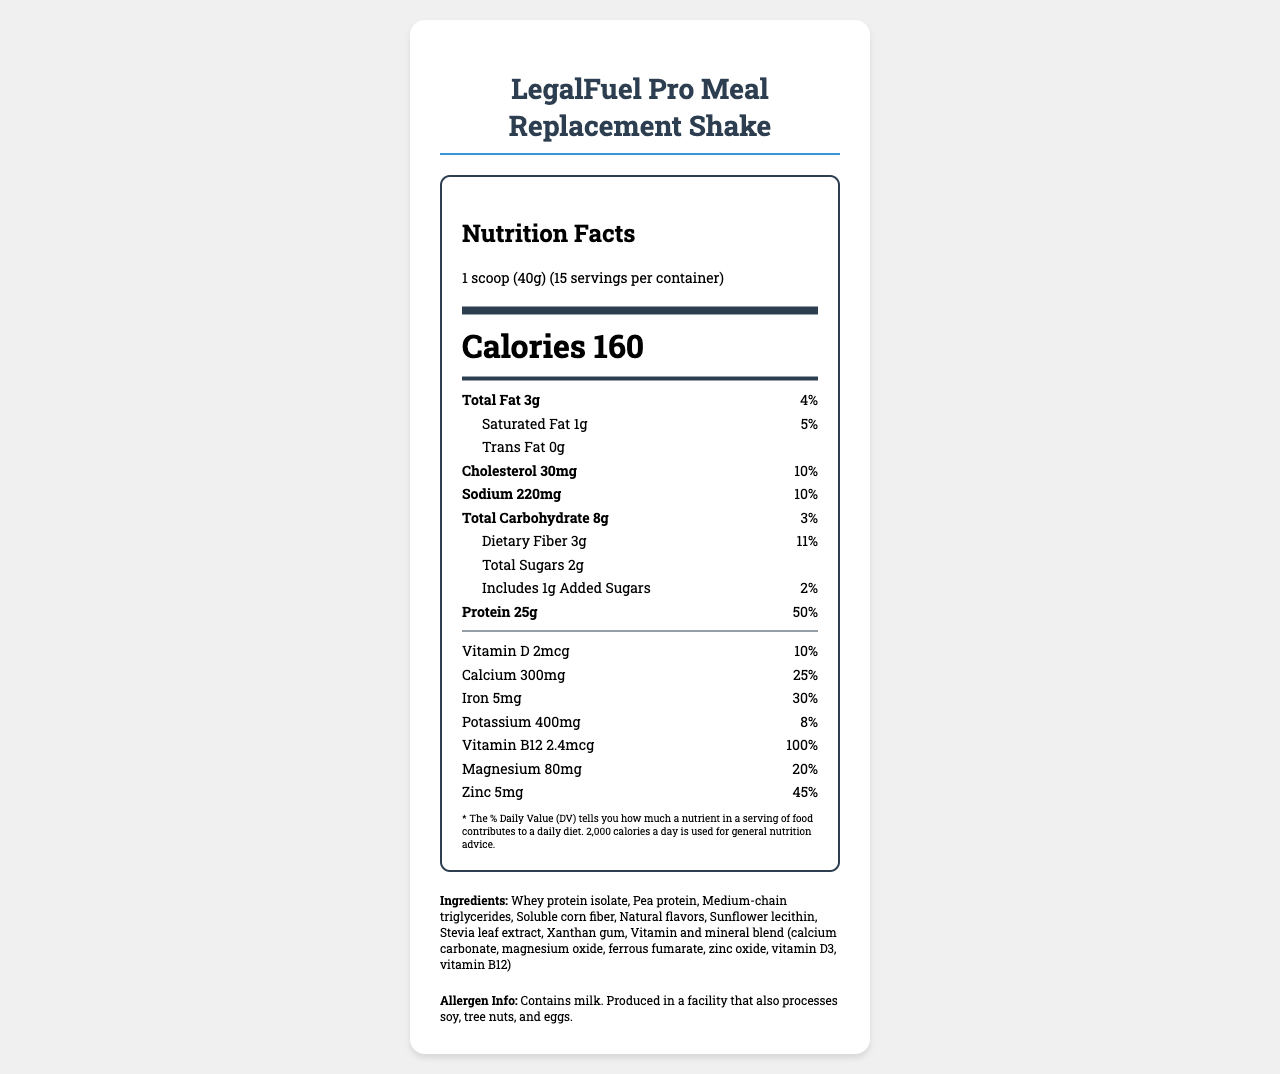what is the product name? The product name is stated at the top of the document.
Answer: LegalFuel Pro Meal Replacement Shake what is the serving size? The serving size is displayed right below the product name within the nutrition label.
Answer: 1 scoop (40g) how many calories are there per serving? The number of calories per serving is clearly indicated in bold, large font on the nutrition facts label.
Answer: 160 what is the amount of total sugars per serving? The amount of total sugars is listed under the carbohydrate section of the nutrition facts label.
Answer: 2g what is the daily value percentage for protein? The daily value percentage for protein is provided in the protein section of the nutrition facts label.
Answer: 50% does this product contain any allergens? The allergen information states that it contains milk and is produced in a facility that processes soy, tree nuts, and eggs.
Answer: Yes how many servings are there per container? The number of servings per container is given in the serving information below the nutrition facts heading.
Answer: 15 what are the total fats per serving, and what is their daily value percentage? The total fat amount is 3g and its daily value percentage is listed as 4% in the fats section of the nutrition label.
Answer: 3g, 4% what is the amount of dietary fiber per serving? The dietary fiber amount is listed under the carbohydrate section of the nutrition facts label.
Answer: 3g what are the product claims made on the document? These product claims are stated under the preparation instructions and product claims section of the document.
Answer: High in protein, Low in sugar, Good source of fiber, Contains essential vitamins and minerals what is the daily value percentage for cholesterol? A. 5% B. 10% C. 15% D. 20% The daily value percentage for cholesterol is listed as 10% in the relevant section of the nutrition facts label.
Answer: B. 10% which vitamin does the product provide 100% of the daily value? A. Vitamin D B. Vitamin B12 C. Vitamin A D. Vitamin C The document states that the product provides 100% of the daily value for Vitamin B12, as indicated in the vitamin section.
Answer: B. Vitamin B12 is the product suitable for vegans? The allergen info indicates the presence of milk, which makes it unsuitable for vegans.
Answer: No can we determine if the product is gluten-free? The document does not provide any specific information about whether the product is gluten-free.
Answer: Not enough information summarize the main idea of this document. The document focuses on presenting comprehensive nutritional facts and product details for the LegalFuel Pro Meal Replacement Shake, highlighting its high protein content and low sugar, making it suitable for busy legal professionals.
Answer: The document provides detailed nutritional information for the LegalFuel Pro Meal Replacement Shake, which is a high-protein, low-sugar meal replacement designed for busy legal professionals. It includes calorie content, nutrient amounts, daily value percentages, ingredients, allergen information, storage and preparation instructions, product claims, and key benefits. 